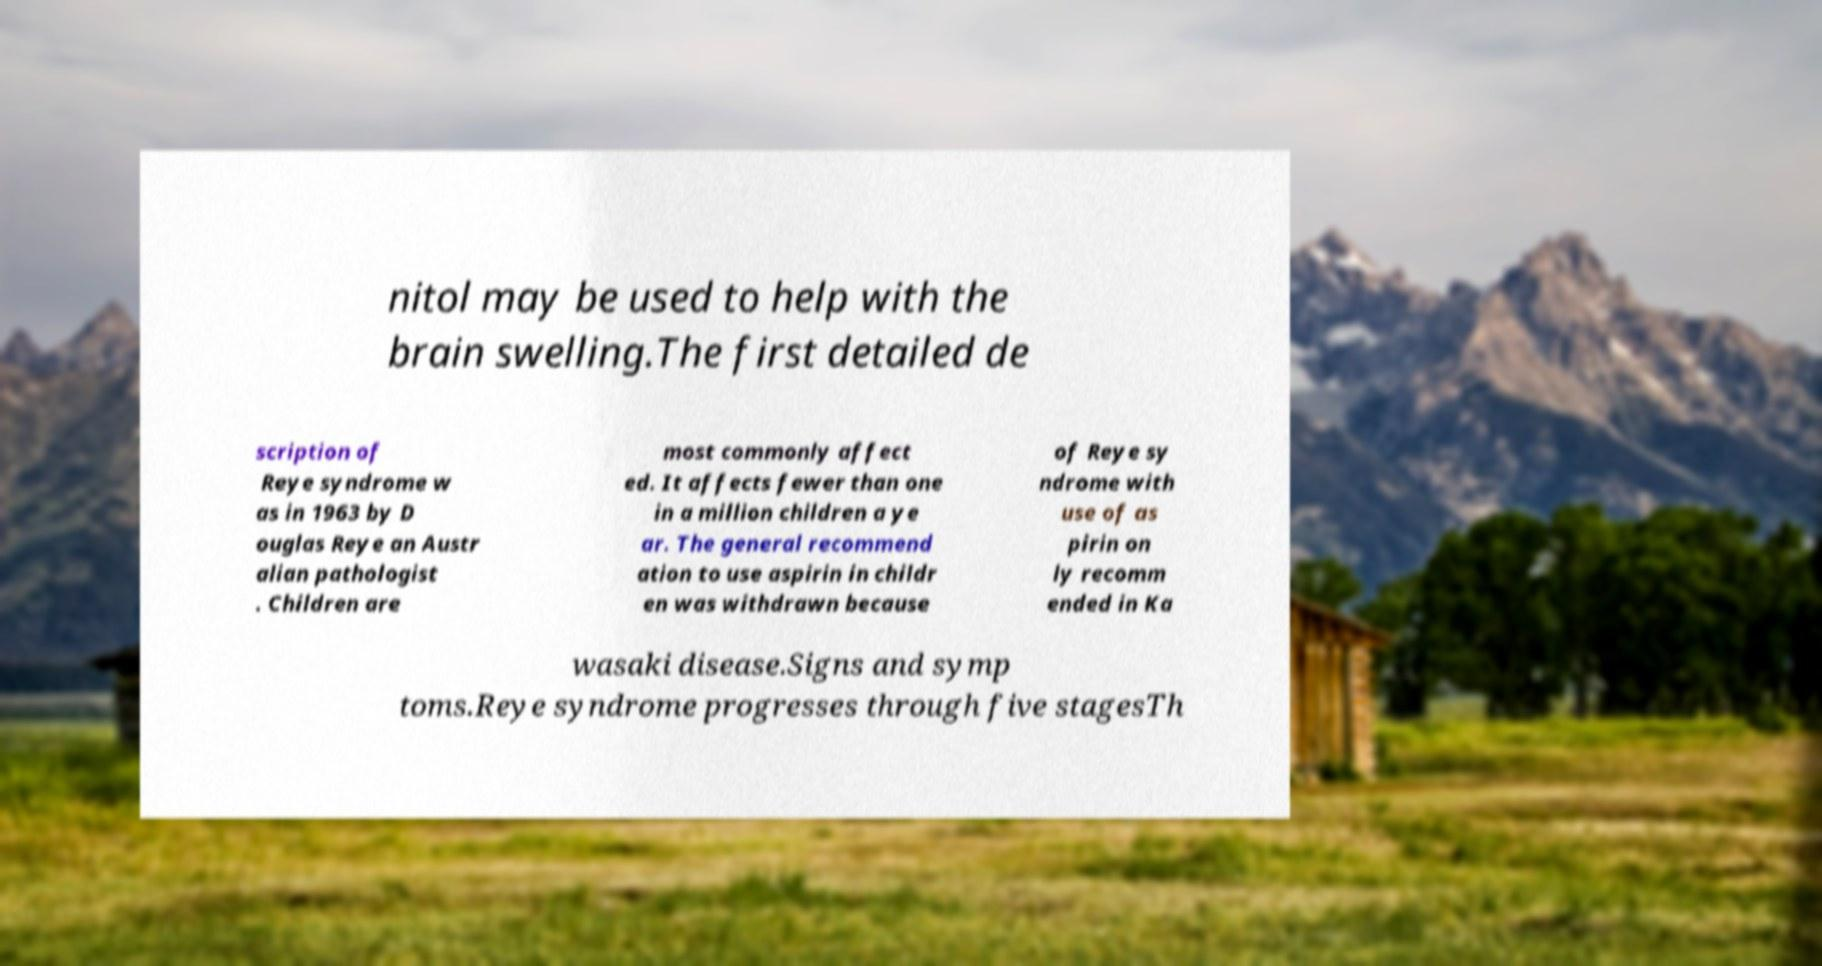For documentation purposes, I need the text within this image transcribed. Could you provide that? nitol may be used to help with the brain swelling.The first detailed de scription of Reye syndrome w as in 1963 by D ouglas Reye an Austr alian pathologist . Children are most commonly affect ed. It affects fewer than one in a million children a ye ar. The general recommend ation to use aspirin in childr en was withdrawn because of Reye sy ndrome with use of as pirin on ly recomm ended in Ka wasaki disease.Signs and symp toms.Reye syndrome progresses through five stagesTh 